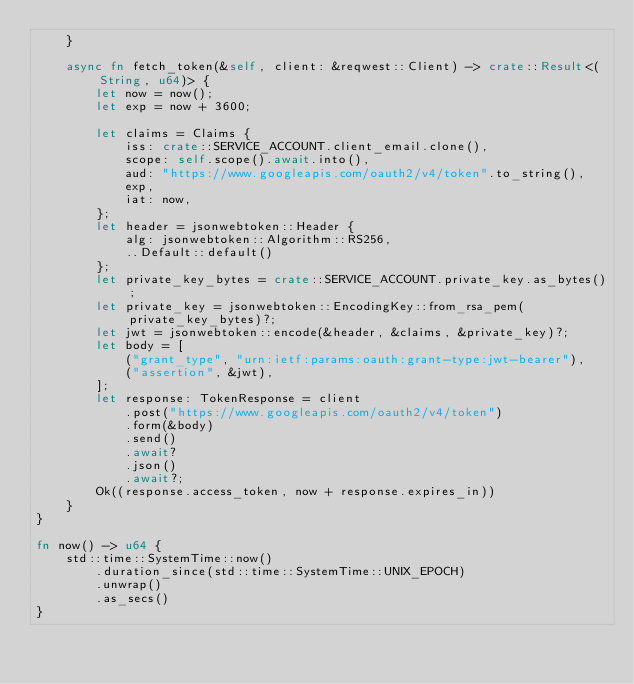<code> <loc_0><loc_0><loc_500><loc_500><_Rust_>    }

    async fn fetch_token(&self, client: &reqwest::Client) -> crate::Result<(String, u64)> {
        let now = now();
        let exp = now + 3600;

        let claims = Claims {
            iss: crate::SERVICE_ACCOUNT.client_email.clone(),
            scope: self.scope().await.into(),
            aud: "https://www.googleapis.com/oauth2/v4/token".to_string(),
            exp,
            iat: now,
        };
        let header = jsonwebtoken::Header {
            alg: jsonwebtoken::Algorithm::RS256,
            ..Default::default()
        };
        let private_key_bytes = crate::SERVICE_ACCOUNT.private_key.as_bytes();
        let private_key = jsonwebtoken::EncodingKey::from_rsa_pem(private_key_bytes)?;
        let jwt = jsonwebtoken::encode(&header, &claims, &private_key)?;
        let body = [
            ("grant_type", "urn:ietf:params:oauth:grant-type:jwt-bearer"),
            ("assertion", &jwt),
        ];
        let response: TokenResponse = client
            .post("https://www.googleapis.com/oauth2/v4/token")
            .form(&body)
            .send()
            .await?
            .json()
            .await?;
        Ok((response.access_token, now + response.expires_in))
    }
}

fn now() -> u64 {
    std::time::SystemTime::now()
        .duration_since(std::time::SystemTime::UNIX_EPOCH)
        .unwrap()
        .as_secs()
}
</code> 